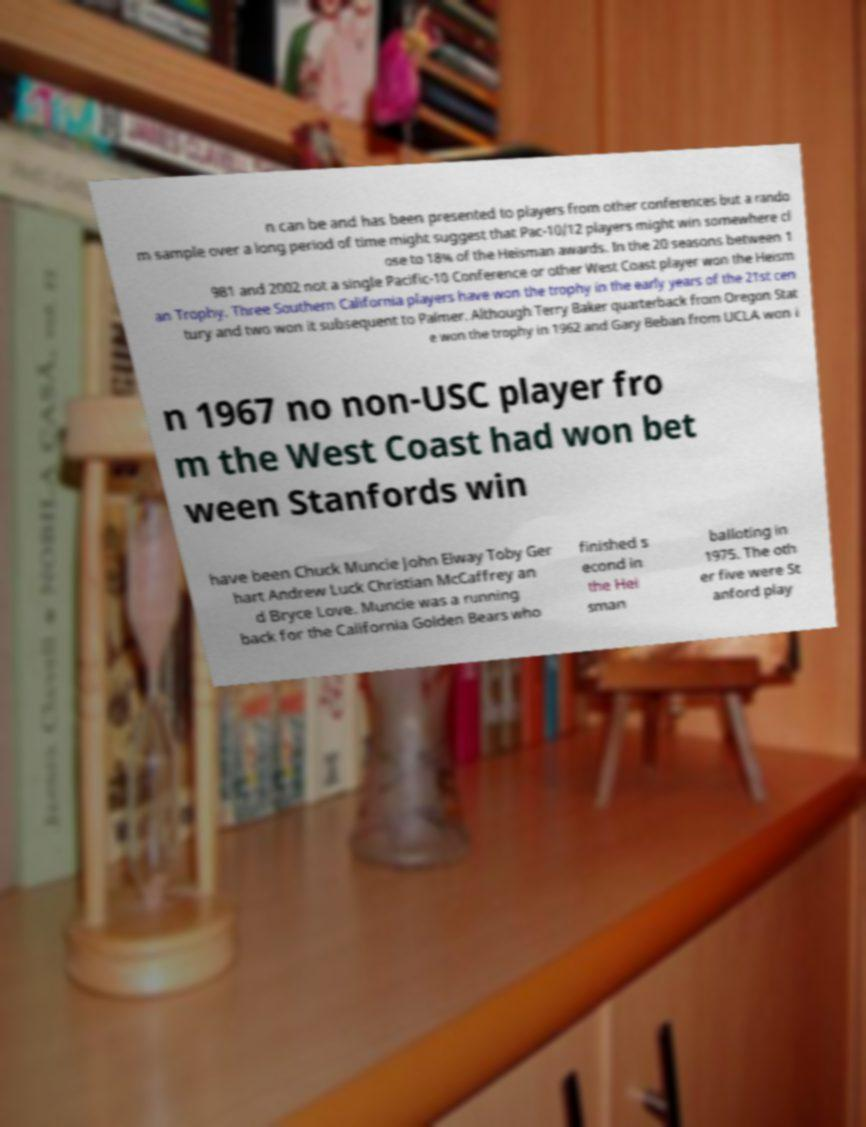What messages or text are displayed in this image? I need them in a readable, typed format. n can be and has been presented to players from other conferences but a rando m sample over a long period of time might suggest that Pac-10/12 players might win somewhere cl ose to 18% of the Heisman awards. In the 20 seasons between 1 981 and 2002 not a single Pacific-10 Conference or other West Coast player won the Heism an Trophy. Three Southern California players have won the trophy in the early years of the 21st cen tury and two won it subsequent to Palmer. Although Terry Baker quarterback from Oregon Stat e won the trophy in 1962 and Gary Beban from UCLA won i n 1967 no non-USC player fro m the West Coast had won bet ween Stanfords win have been Chuck Muncie John Elway Toby Ger hart Andrew Luck Christian McCaffrey an d Bryce Love. Muncie was a running back for the California Golden Bears who finished s econd in the Hei sman balloting in 1975. The oth er five were St anford play 